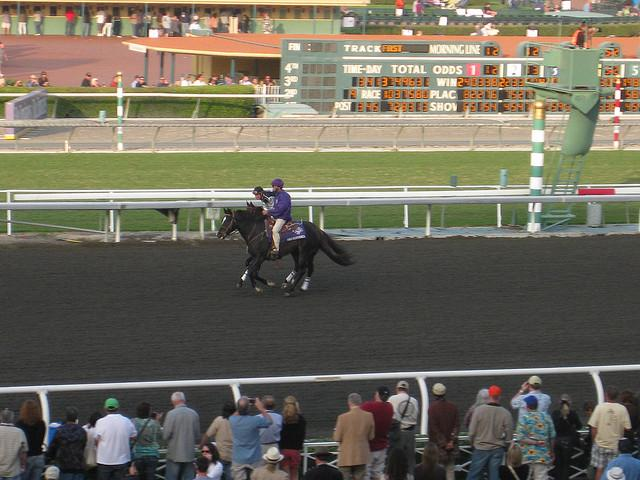What type of event is being held? Please explain your reasoning. race. There are horses in the area that are usually for racing. 